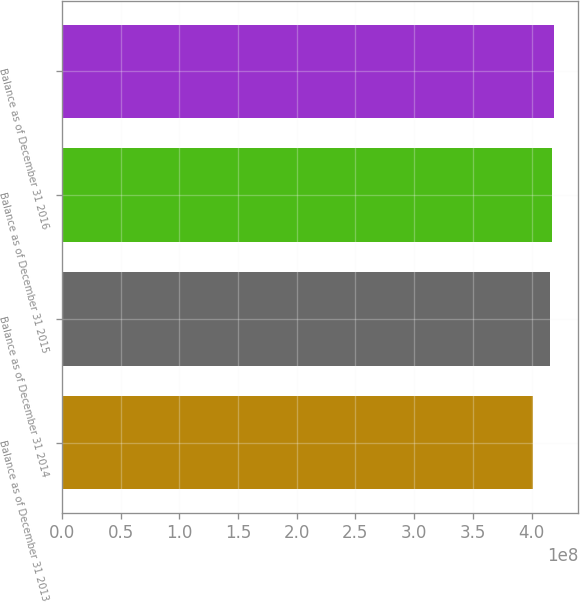Convert chart. <chart><loc_0><loc_0><loc_500><loc_500><bar_chart><fcel>Balance as of December 31 2013<fcel>Balance as of December 31 2014<fcel>Balance as of December 31 2015<fcel>Balance as of December 31 2016<nl><fcel>4.01127e+08<fcel>4.15506e+08<fcel>4.17152e+08<fcel>4.18798e+08<nl></chart> 